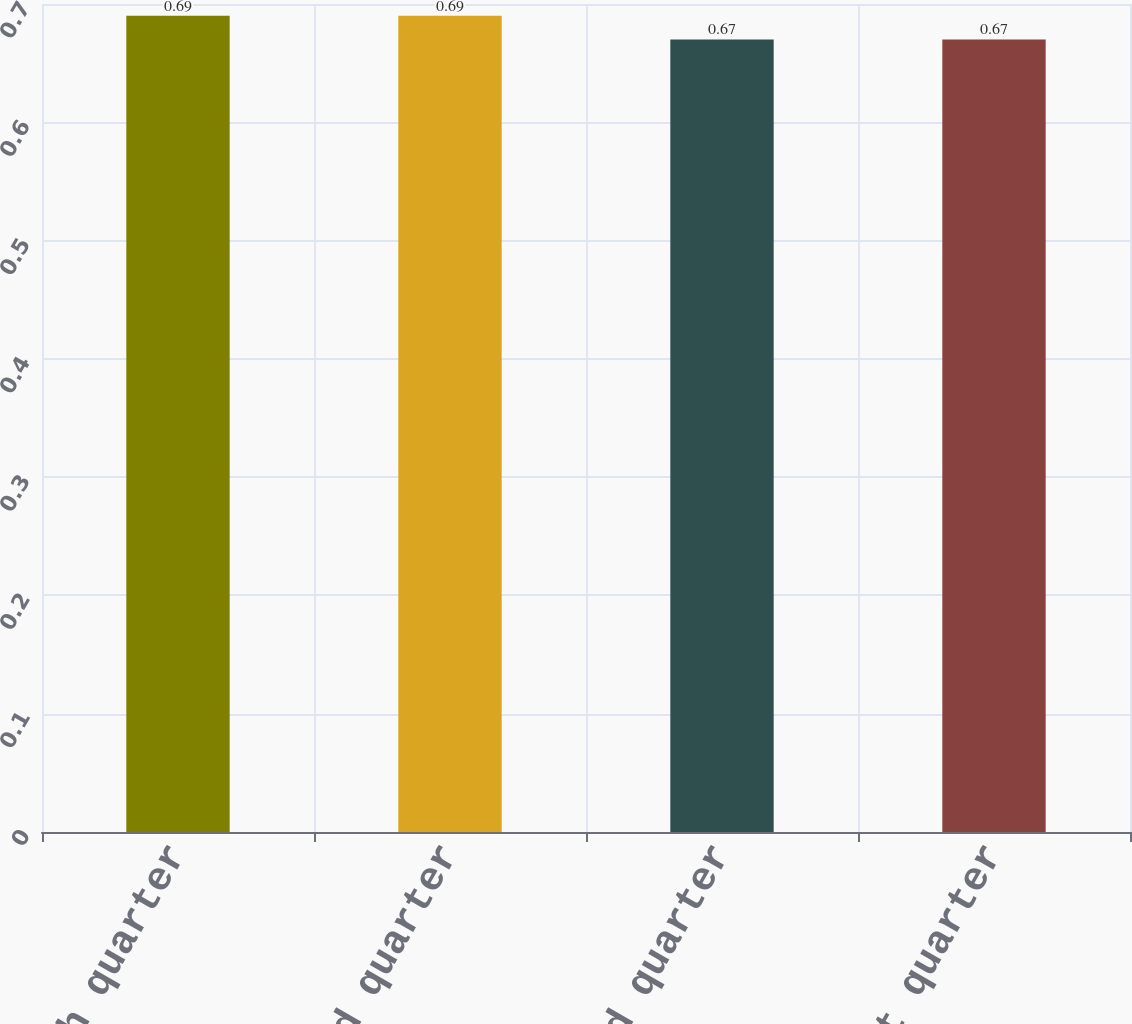Convert chart to OTSL. <chart><loc_0><loc_0><loc_500><loc_500><bar_chart><fcel>Fourth quarter<fcel>Third quarter<fcel>Second quarter<fcel>First quarter<nl><fcel>0.69<fcel>0.69<fcel>0.67<fcel>0.67<nl></chart> 